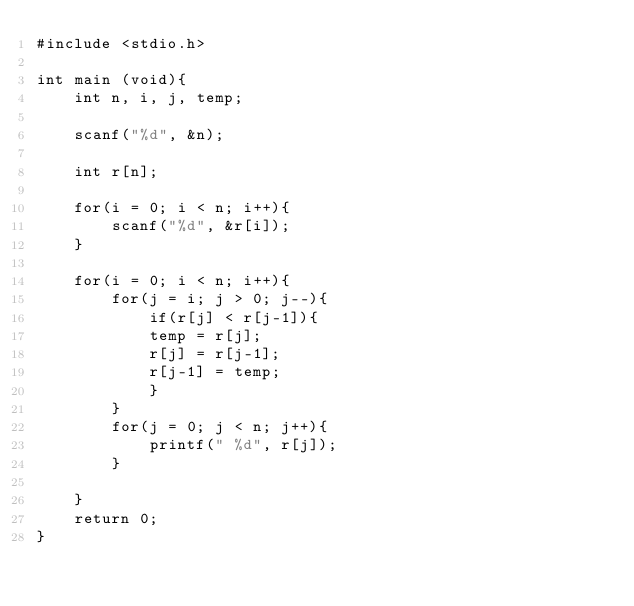Convert code to text. <code><loc_0><loc_0><loc_500><loc_500><_C_>#include <stdio.h>

int main (void){
    int n, i, j, temp;
    
    scanf("%d", &n);
    
    int r[n];
    
    for(i = 0; i < n; i++){
        scanf("%d", &r[i]);
    }
    
    for(i = 0; i < n; i++){
        for(j = i; j > 0; j--){
            if(r[j] < r[j-1]){
            temp = r[j];
            r[j] = r[j-1];
            r[j-1] = temp;
            }
        }
        for(j = 0; j < n; j++){
            printf(" %d", r[j]);
        }

    }
    return 0;
}</code> 